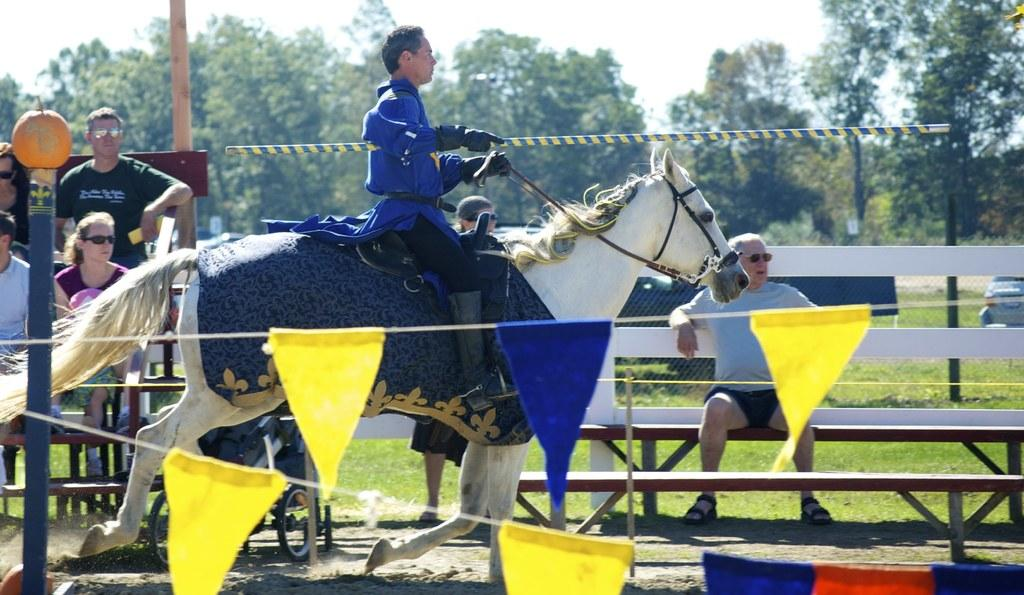What activity is the person in the image engaged in? There is a person riding a horse in the image. What can be seen in the background of the image? There is a pole and trees in the background of the image. What is the condition of the sky in the image? The sky is clear in the image. Are there any other people visible in the image? Yes, there are people sitting on a bench in the image. Can you see any badges on the horse in the image? There are no badges visible on the horse in the image. Are there any ghosts present in the image? There are no ghosts present in the image. 